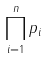Convert formula to latex. <formula><loc_0><loc_0><loc_500><loc_500>\prod _ { i = 1 } ^ { n } p _ { i }</formula> 